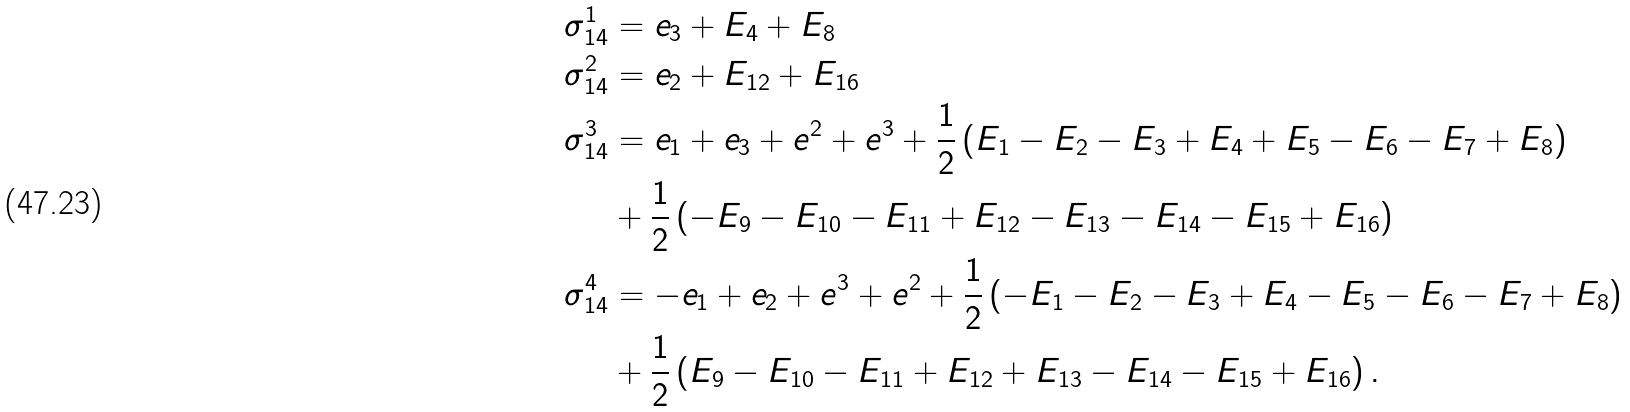Convert formula to latex. <formula><loc_0><loc_0><loc_500><loc_500>\sigma _ { 1 4 } ^ { 1 } & = e _ { 3 } + E _ { 4 } + E _ { 8 } \\ \sigma _ { 1 4 } ^ { 2 } & = e _ { 2 } + E _ { 1 2 } + E _ { 1 6 } \\ \sigma _ { 1 4 } ^ { 3 } & = e _ { 1 } + e _ { 3 } + e ^ { 2 } + e ^ { 3 } + \frac { 1 } { 2 } \left ( E _ { 1 } - E _ { 2 } - E _ { 3 } + E _ { 4 } + E _ { 5 } - E _ { 6 } - E _ { 7 } + E _ { 8 } \right ) \\ & + \frac { 1 } { 2 } \left ( - E _ { 9 } - E _ { 1 0 } - E _ { 1 1 } + E _ { 1 2 } - E _ { 1 3 } - E _ { 1 4 } - E _ { 1 5 } + E _ { 1 6 } \right ) \\ \sigma _ { 1 4 } ^ { 4 } & = - e _ { 1 } + e _ { 2 } + e ^ { 3 } + e ^ { 2 } + \frac { 1 } { 2 } \left ( - E _ { 1 } - E _ { 2 } - E _ { 3 } + E _ { 4 } - E _ { 5 } - E _ { 6 } - E _ { 7 } + E _ { 8 } \right ) \\ & + \frac { 1 } { 2 } \left ( E _ { 9 } - E _ { 1 0 } - E _ { 1 1 } + E _ { 1 2 } + E _ { 1 3 } - E _ { 1 4 } - E _ { 1 5 } + E _ { 1 6 } \right ) .</formula> 